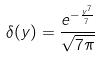Convert formula to latex. <formula><loc_0><loc_0><loc_500><loc_500>\delta ( y ) = \frac { e ^ { - \frac { y ^ { 7 } } { 7 } } } { \sqrt { 7 \pi } }</formula> 